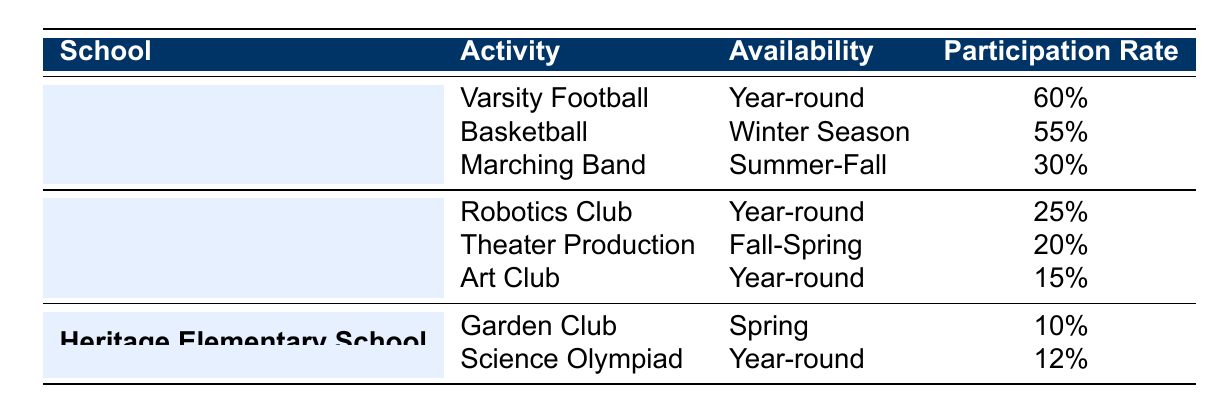What extracurricular activity at Chardon High School has the highest participation rate? By examining the "Participation Rate" for Chardon High School activities, "Varsity Football" has the highest rate of 60%, compared to "Basketball" at 55% and "Marching Band" at 30%.
Answer: Varsity Football Which school offers an activity in the Spring? The "Garden Club" at Heritage Elementary School is available in the Spring, while no other activities in the table are listed during that time.
Answer: Heritage Elementary School What is the average participation rate of extracurricular activities at Chardon Middle School? To find the average: (25% + 20% + 15%) = 60%. Then, divide by the number of activities (3), so 60% / 3 = 20%.
Answer: 20% Does Chardon Middle School have any year-round activities? Yes, both "Robotics Club" and "Art Club" are available year-round at Chardon Middle School.
Answer: Yes Which activity has the lowest participation rate among all schools? The "Garden Club" at Heritage Elementary School has the lowest participation rate, which is 10%, compared to the other activities listed.
Answer: Garden Club 